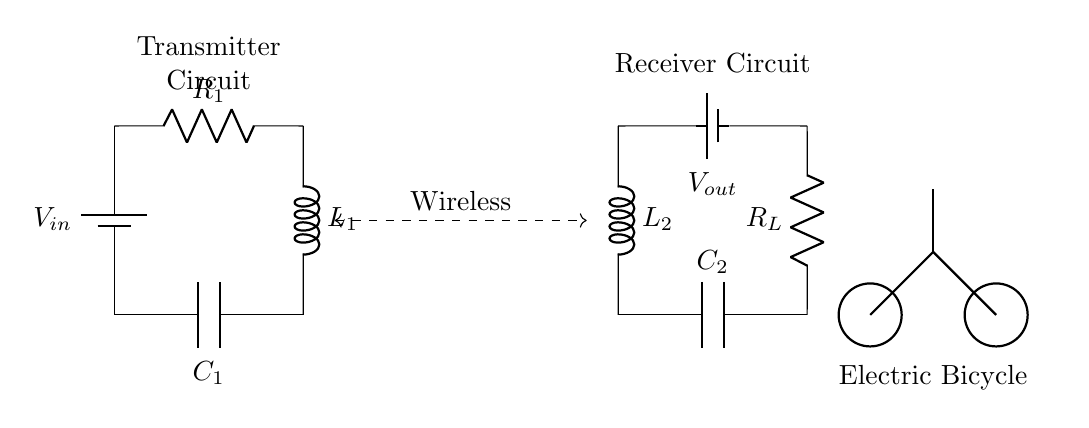What is the input voltage of the circuit? The input voltage is denoted as V_in, which is shown connected to the battery symbol on the transmitter side of the circuit diagram.
Answer: V_in What is the role of the inductor L1 in the transmitter circuit? Inductor L1 is part of a resonant circuit; it is used to create an oscillating magnetic field, enabling the transfer of energy wirelessly to the receiver.
Answer: Energy transfer What are the components used in the receiver circuit? The components in the receiver circuit include an inductor (L2), a capacitor (C2), and a load resistor (R_L), which are arranged to convert wireless energy back into electrical energy.
Answer: Inductor, capacitor, resistor How many capacitors are present in the circuit? There are two capacitors in the circuit: C1 in the transmitter circuit and C2 in the receiver circuit.
Answer: Two What is the purpose of the wireless coupling indicated in the diagram? The wireless coupling is represented by the dashed line connecting the transmitter and receiver circuits; its purpose is to indicate the area where energy is transferred from the transmitter to the receiver without direct contact.
Answer: Energy transfer What is the load resistor labeled as in the receiver circuit? The load resistor in the receiver circuit is labeled as R_L, which indicates its function as a load for the electrical output.
Answer: R_L What type of circuit is shown in the diagram? The diagram depicts a wireless charging circuit specifically designed for electric bicycles, focusing on energy transfer mechanisms without physical connections.
Answer: Wireless charging circuit 